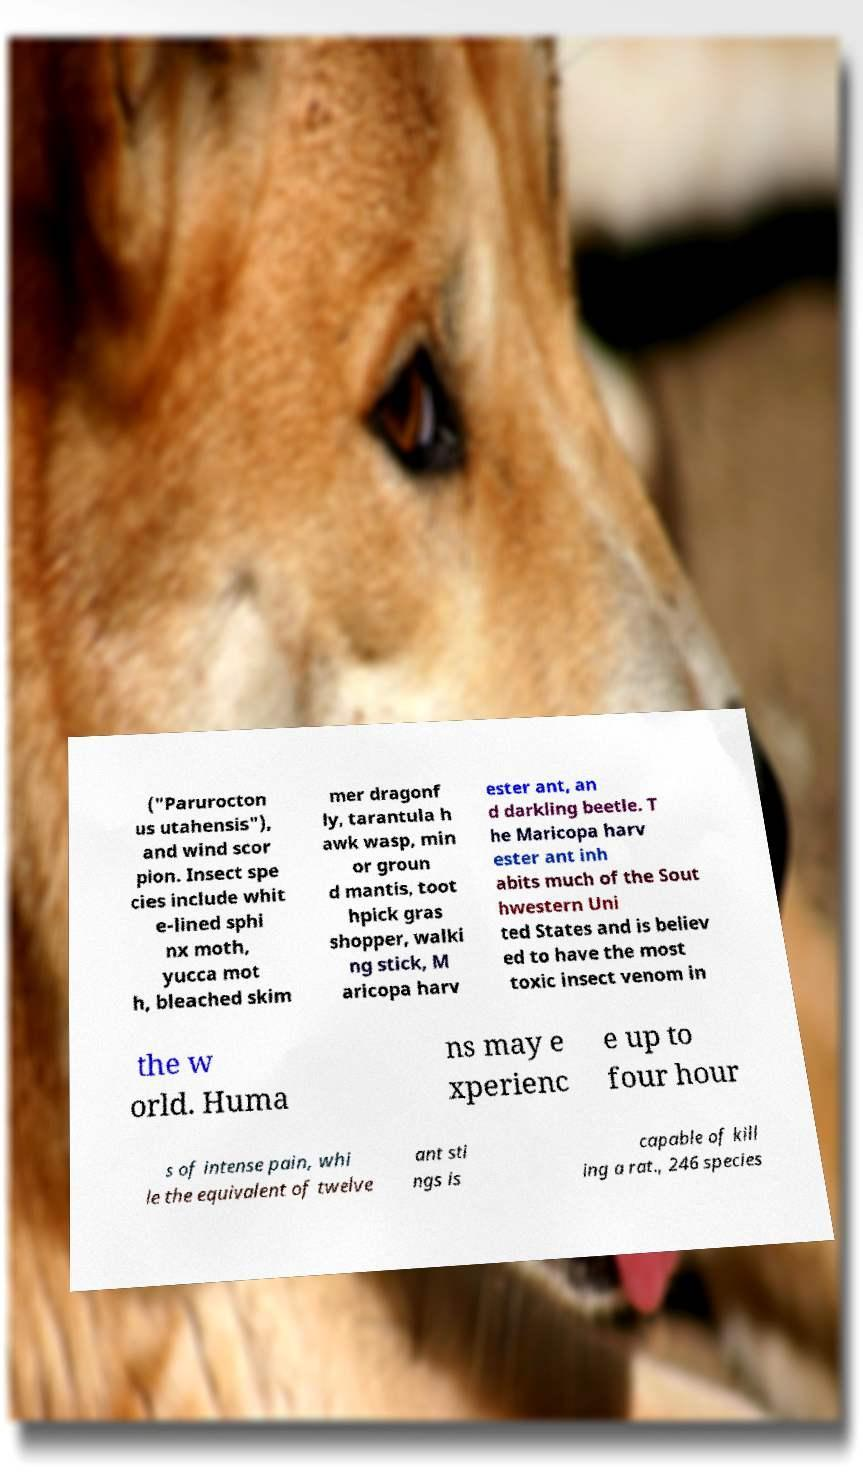Could you assist in decoding the text presented in this image and type it out clearly? ("Parurocton us utahensis"), and wind scor pion. Insect spe cies include whit e-lined sphi nx moth, yucca mot h, bleached skim mer dragonf ly, tarantula h awk wasp, min or groun d mantis, toot hpick gras shopper, walki ng stick, M aricopa harv ester ant, an d darkling beetle. T he Maricopa harv ester ant inh abits much of the Sout hwestern Uni ted States and is believ ed to have the most toxic insect venom in the w orld. Huma ns may e xperienc e up to four hour s of intense pain, whi le the equivalent of twelve ant sti ngs is capable of kill ing a rat., 246 species 